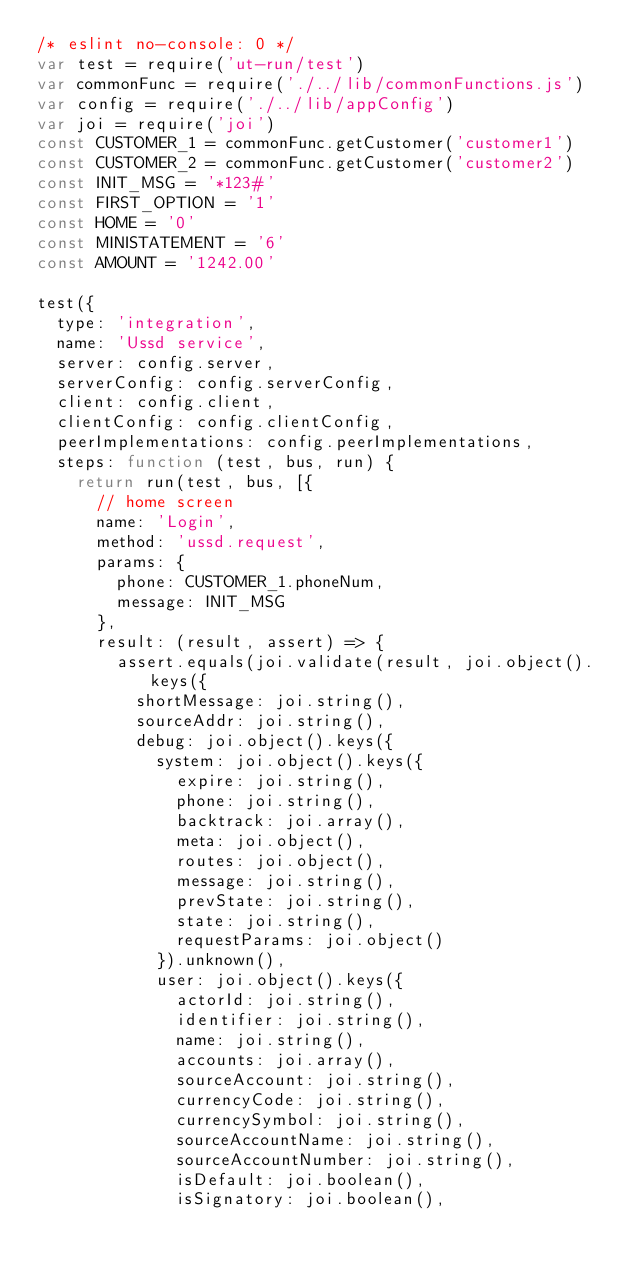<code> <loc_0><loc_0><loc_500><loc_500><_JavaScript_>/* eslint no-console: 0 */
var test = require('ut-run/test')
var commonFunc = require('./../lib/commonFunctions.js')
var config = require('./../lib/appConfig')
var joi = require('joi')
const CUSTOMER_1 = commonFunc.getCustomer('customer1')
const CUSTOMER_2 = commonFunc.getCustomer('customer2')
const INIT_MSG = '*123#'
const FIRST_OPTION = '1'
const HOME = '0'
const MINISTATEMENT = '6'
const AMOUNT = '1242.00'

test({
  type: 'integration',
  name: 'Ussd service',
  server: config.server,
  serverConfig: config.serverConfig,
  client: config.client,
  clientConfig: config.clientConfig,
  peerImplementations: config.peerImplementations,
  steps: function (test, bus, run) {
    return run(test, bus, [{
      // home screen
      name: 'Login',
      method: 'ussd.request',
      params: {
        phone: CUSTOMER_1.phoneNum,
        message: INIT_MSG
      },
      result: (result, assert) => {
        assert.equals(joi.validate(result, joi.object().keys({
          shortMessage: joi.string(),
          sourceAddr: joi.string(),
          debug: joi.object().keys({
            system: joi.object().keys({
              expire: joi.string(),
              phone: joi.string(),
              backtrack: joi.array(),
              meta: joi.object(),
              routes: joi.object(),
              message: joi.string(),
              prevState: joi.string(),
              state: joi.string(),
              requestParams: joi.object()
            }).unknown(),
            user: joi.object().keys({
              actorId: joi.string(),
              identifier: joi.string(),
              name: joi.string(),
              accounts: joi.array(),
              sourceAccount: joi.string(),
              currencyCode: joi.string(),
              currencySymbol: joi.string(),
              sourceAccountName: joi.string(),
              sourceAccountNumber: joi.string(),
              isDefault: joi.boolean(),
              isSignatory: joi.boolean(),</code> 